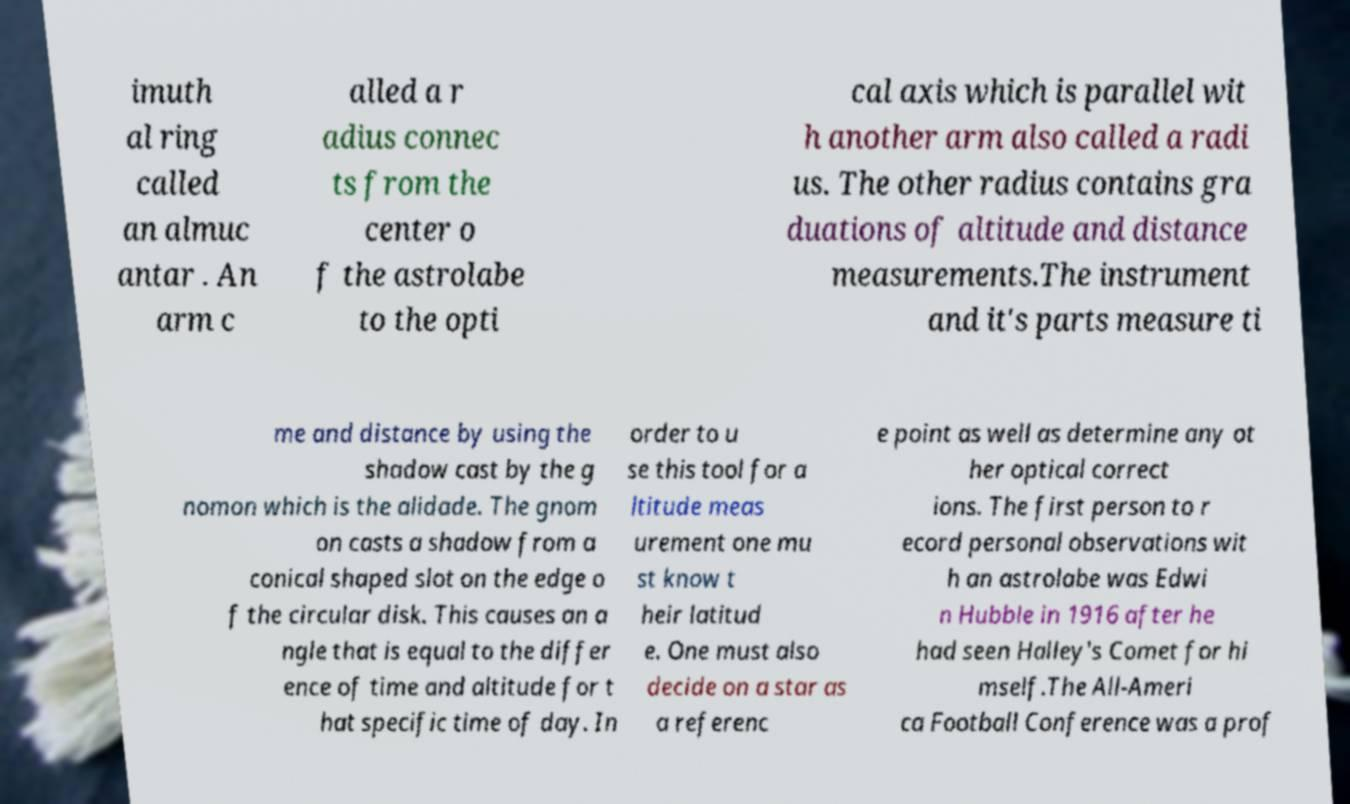What messages or text are displayed in this image? I need them in a readable, typed format. imuth al ring called an almuc antar . An arm c alled a r adius connec ts from the center o f the astrolabe to the opti cal axis which is parallel wit h another arm also called a radi us. The other radius contains gra duations of altitude and distance measurements.The instrument and it's parts measure ti me and distance by using the shadow cast by the g nomon which is the alidade. The gnom on casts a shadow from a conical shaped slot on the edge o f the circular disk. This causes an a ngle that is equal to the differ ence of time and altitude for t hat specific time of day. In order to u se this tool for a ltitude meas urement one mu st know t heir latitud e. One must also decide on a star as a referenc e point as well as determine any ot her optical correct ions. The first person to r ecord personal observations wit h an astrolabe was Edwi n Hubble in 1916 after he had seen Halley's Comet for hi mself.The All-Ameri ca Football Conference was a prof 